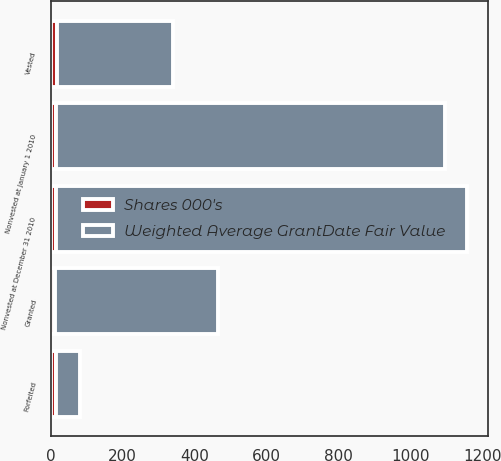Convert chart. <chart><loc_0><loc_0><loc_500><loc_500><stacked_bar_chart><ecel><fcel>Nonvested at January 1 2010<fcel>Granted<fcel>Vested<fcel>Forfeited<fcel>Nonvested at December 31 2010<nl><fcel>Weighted Average GrantDate Fair Value<fcel>1080<fcel>453<fcel>323<fcel>66<fcel>1144<nl><fcel>Shares 000's<fcel>15.85<fcel>11.35<fcel>16.51<fcel>15.54<fcel>13.9<nl></chart> 